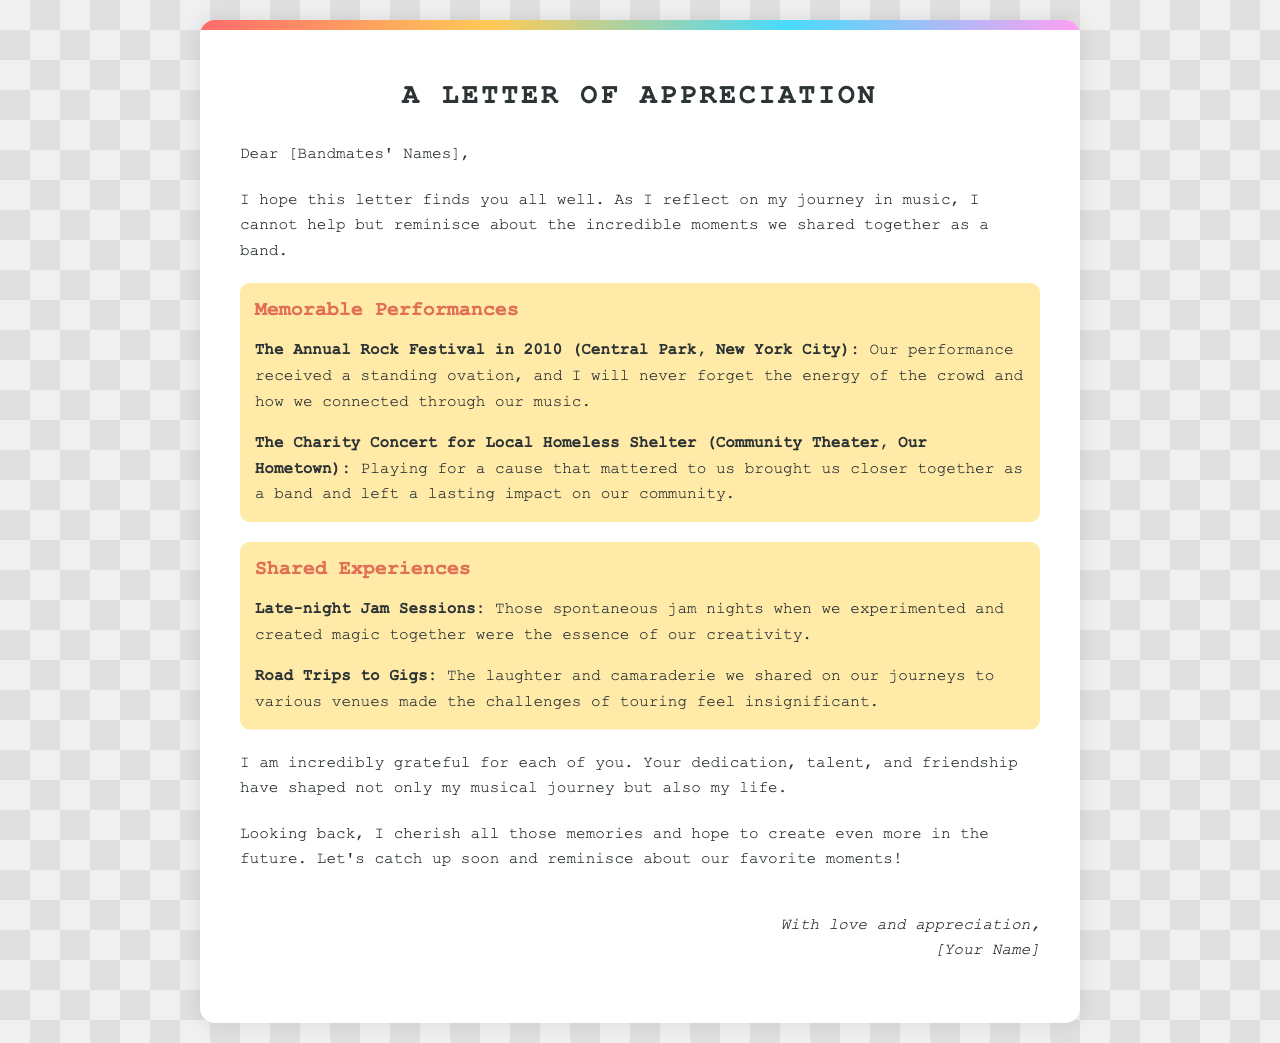What is the title of the letter? The title can be found at the beginning of the document and is explicitly stated.
Answer: A Letter of Appreciation Who wrote the letter? The author's name is indicated at the end of the letter.
Answer: [Your Name] In what year did the Annual Rock Festival take place? The letter mentions the event and specifies the year clearly.
Answer: 2010 What venue hosted the Charity Concert? The letter specifies the location for this event.
Answer: Community Theater What kind of performances does the letter highlight? The letter discusses different types of performances that were memorable.
Answer: Memorable Performances What aspect of band life does the letter mention regarding road trips? The letter reflects on experiences that occurred during these journeys.
Answer: Laughter and camaraderie What type of events are the highlighted performances categorized under? The letter groups experiences into distinct categories.
Answer: Memorable Performances Why does the author feel grateful towards the bandmates? The letter expresses appreciation based on several shared experiences.
Answer: Dedication, talent, and friendship 